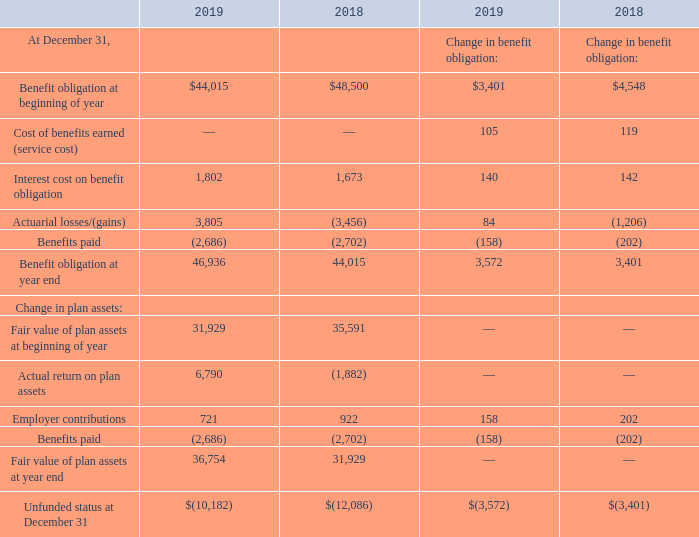Postretirement Benefit Plans
The Company also provides certain postretirement health care and life insurance benefits to qualifying domestic retirees and their eligible dependents. The health care plan for shore-based employees and their dependents and seagoing licensed deck officers (“Deck Officers”) and their dependents is contributory at retirement, while the life insurance plan for all employees is noncontributory.
In general, postretirement medical coverage is provided to shore-based employees hired prior to January 1, 2005 and all Deck Officers who retire and have met minimum age and service requirements under a formula related to total years of service. The Company no longer provides prescription drug coverage to its retirees or their beneficiaries once they reach age 65.
The Company does not currently fund these benefit arrangements and has the right to amend or terminate the health care and life insurance benefits at any time.
Information with respect to the domestic pension and postretirement benefit plans for which the Company uses a December 31 measurement date, follow:
What benefits are provided by the company to qualifying domestic retirees and their eligible dependents? Certain postretirement health care and life insurance benefits. What is the change in Interest cost on benefit obligation for pension benefits from December 31, 2018 and 2019? 1,802-1,673
Answer: 129. What is the average Interest cost on benefit obligation for pension benefits for December 31, 2018 and 2019? (1,802+1,673) / 2
Answer: 1737.5. In which year was Benefit obligation at beginning of year for pension benefits less than 45,000? Locate and analyze benefit obligation at beginning of year in row 3
answer: 2019. What was the Interest cost on benefit obligation in 2019 and 2018 respectively? 1,802, 1,673. What was the Benefit obligation at year end of 2019 for pension benefits? 46,936. 